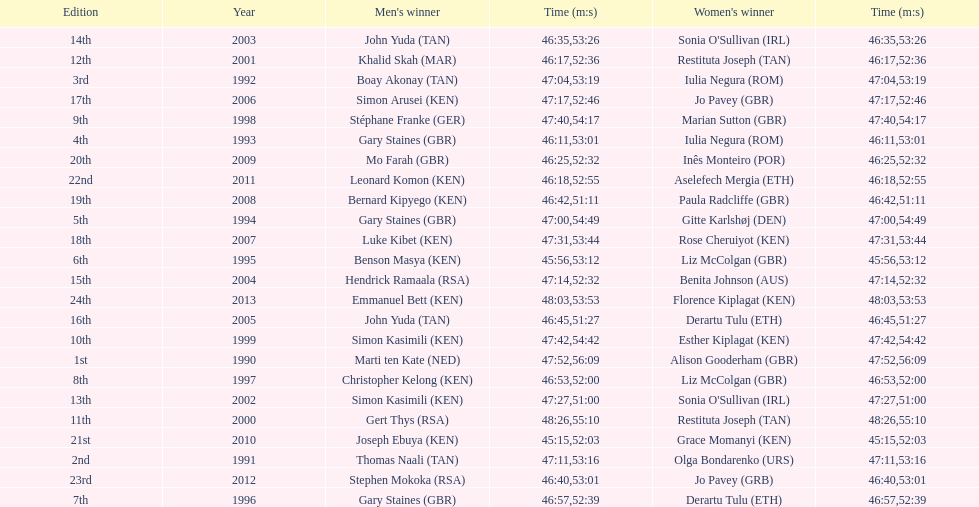Who has the fastest recorded finish for the men's bupa great south run, between 1990 and 2013? Joseph Ebuya (KEN). 